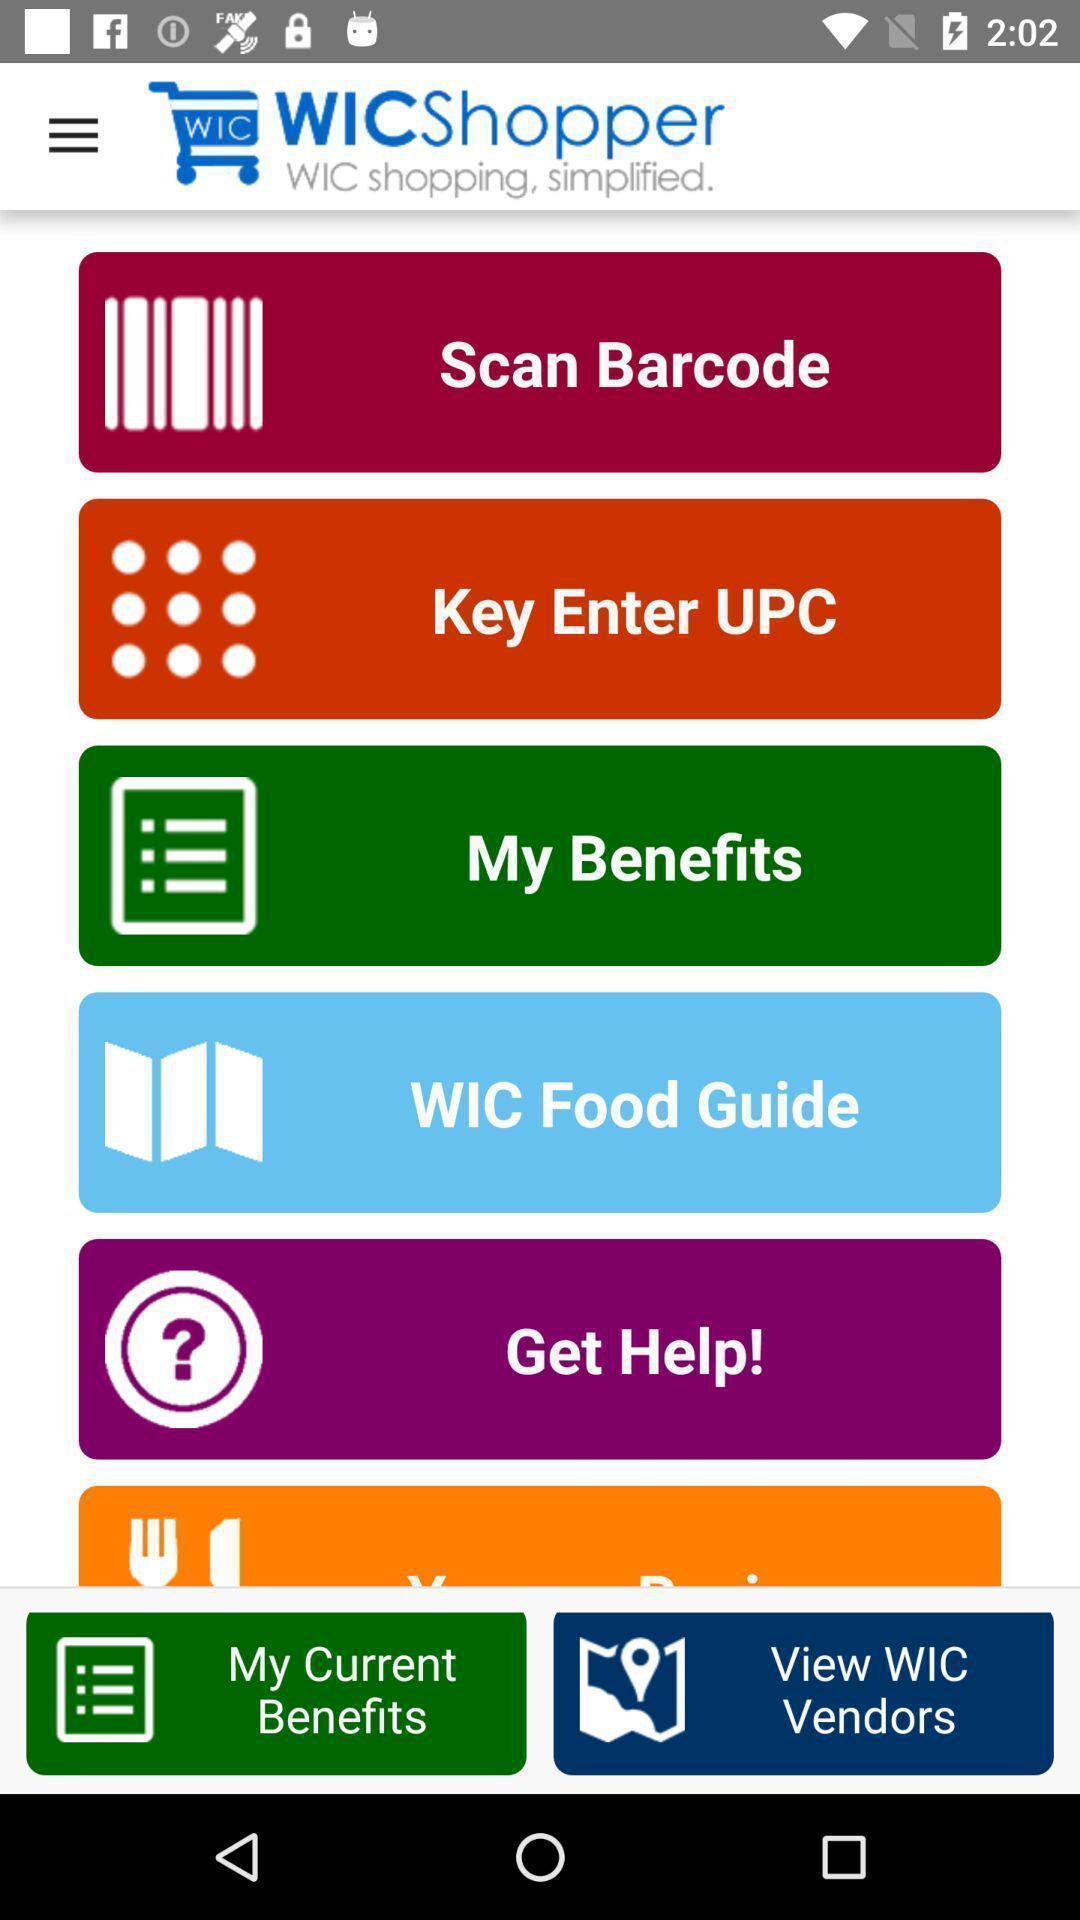Summarize the main components in this picture. Set of options in a shopping application. 